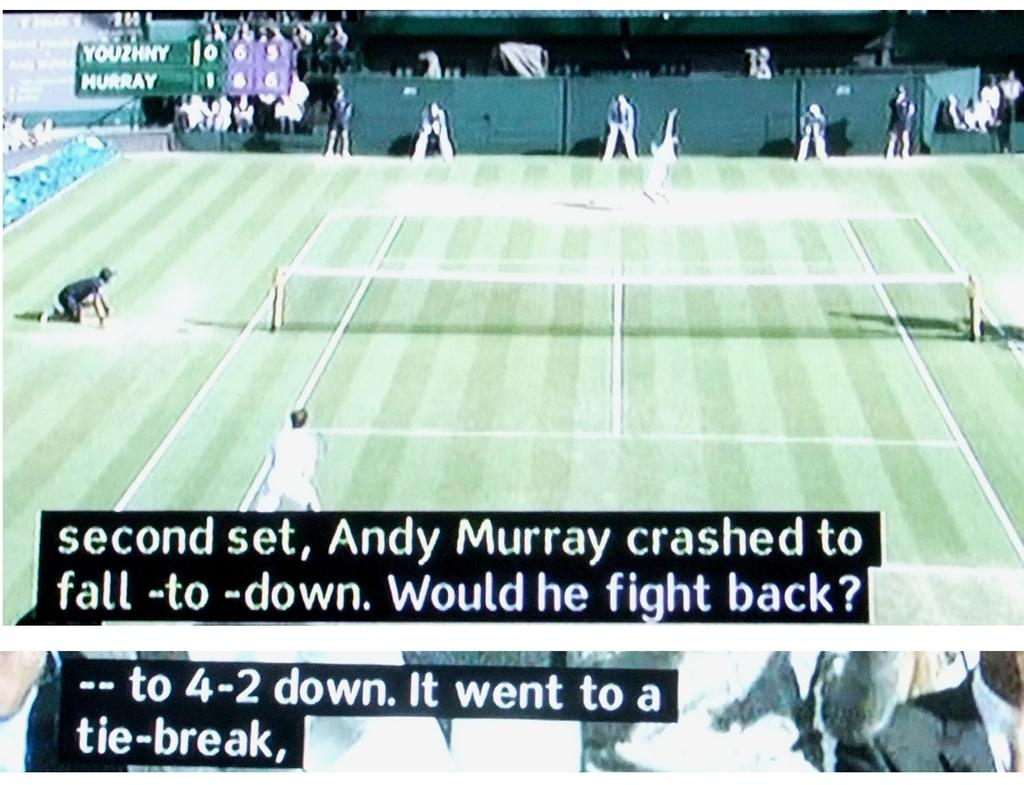<image>
Give a short and clear explanation of the subsequent image. A tennis match between Youzhny and Murray is subtitled. 